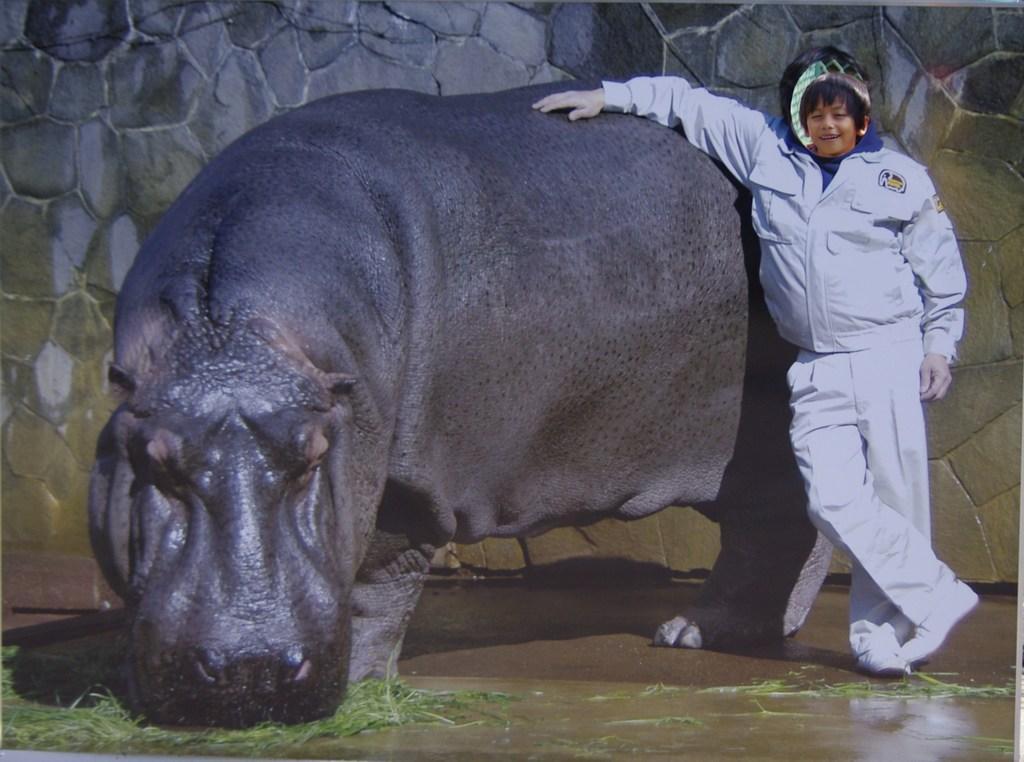Describe this image in one or two sentences. In the image on the brown color floor there is a hippopotamus is standing. And it is eating the grass which is on the floor. Beside that there is a person with a white dress is stunning. Behind them in the background there is a stone wall. 